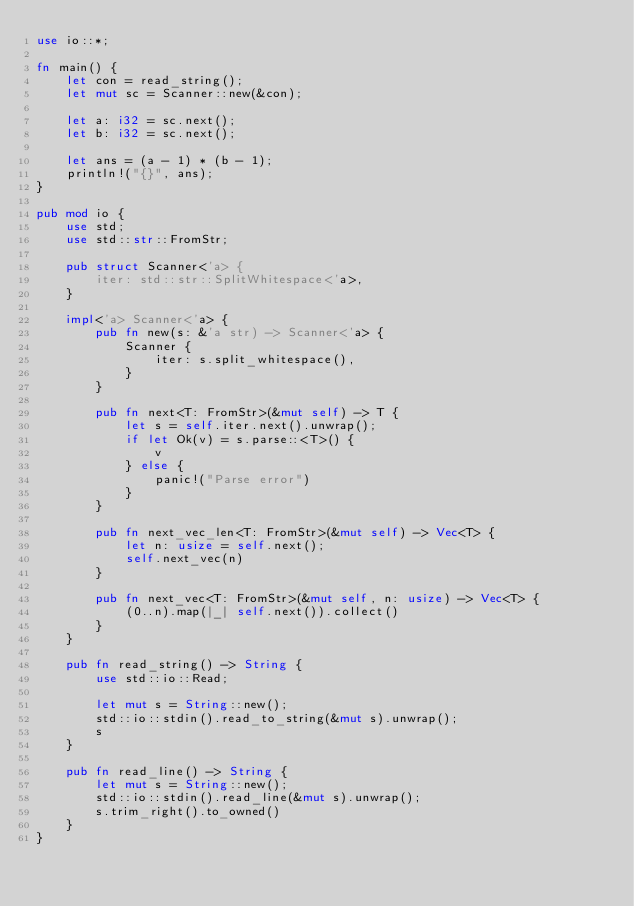Convert code to text. <code><loc_0><loc_0><loc_500><loc_500><_Rust_>use io::*;

fn main() {
    let con = read_string();
    let mut sc = Scanner::new(&con);

    let a: i32 = sc.next();
    let b: i32 = sc.next();

    let ans = (a - 1) * (b - 1);
    println!("{}", ans);
}

pub mod io {
    use std;
    use std::str::FromStr;

    pub struct Scanner<'a> {
        iter: std::str::SplitWhitespace<'a>,
    }

    impl<'a> Scanner<'a> {
        pub fn new(s: &'a str) -> Scanner<'a> {
            Scanner {
                iter: s.split_whitespace(),
            }
        }

        pub fn next<T: FromStr>(&mut self) -> T {
            let s = self.iter.next().unwrap();
            if let Ok(v) = s.parse::<T>() {
                v
            } else {
                panic!("Parse error")
            }
        }

        pub fn next_vec_len<T: FromStr>(&mut self) -> Vec<T> {
            let n: usize = self.next();
            self.next_vec(n)
        }

        pub fn next_vec<T: FromStr>(&mut self, n: usize) -> Vec<T> {
            (0..n).map(|_| self.next()).collect()
        }
    }

    pub fn read_string() -> String {
        use std::io::Read;

        let mut s = String::new();
        std::io::stdin().read_to_string(&mut s).unwrap();
        s
    }

    pub fn read_line() -> String {
        let mut s = String::new();
        std::io::stdin().read_line(&mut s).unwrap();
        s.trim_right().to_owned()
    }
}
</code> 